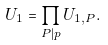Convert formula to latex. <formula><loc_0><loc_0><loc_500><loc_500>U _ { 1 } = \prod _ { P | p } U _ { 1 , P } .</formula> 